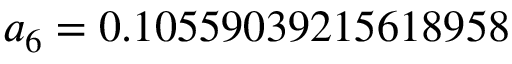Convert formula to latex. <formula><loc_0><loc_0><loc_500><loc_500>a _ { 6 } = 0 . 1 0 5 5 9 0 3 9 2 1 5 6 1 8 9 5 8</formula> 